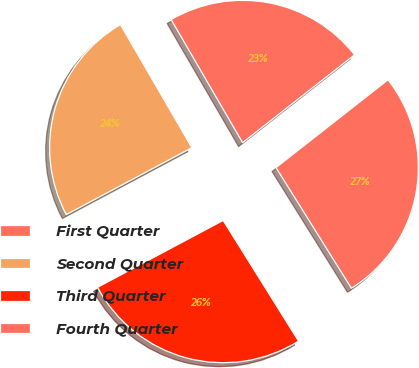Convert chart to OTSL. <chart><loc_0><loc_0><loc_500><loc_500><pie_chart><fcel>First Quarter<fcel>Second Quarter<fcel>Third Quarter<fcel>Fourth Quarter<nl><fcel>22.79%<fcel>24.42%<fcel>26.1%<fcel>26.7%<nl></chart> 